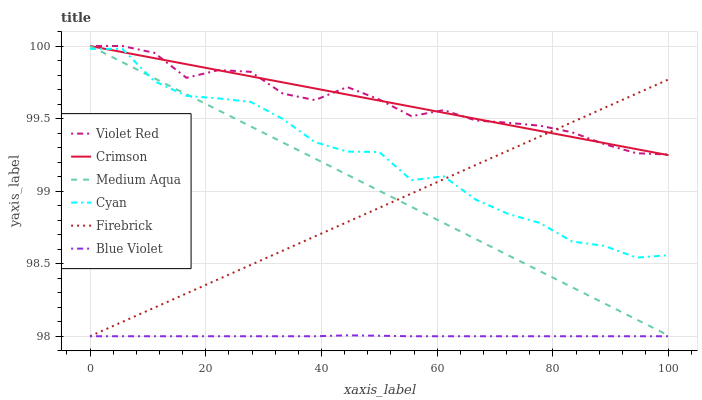Does Blue Violet have the minimum area under the curve?
Answer yes or no. Yes. Does Crimson have the maximum area under the curve?
Answer yes or no. Yes. Does Firebrick have the minimum area under the curve?
Answer yes or no. No. Does Firebrick have the maximum area under the curve?
Answer yes or no. No. Is Firebrick the smoothest?
Answer yes or no. Yes. Is Cyan the roughest?
Answer yes or no. Yes. Is Medium Aqua the smoothest?
Answer yes or no. No. Is Medium Aqua the roughest?
Answer yes or no. No. Does Firebrick have the lowest value?
Answer yes or no. Yes. Does Medium Aqua have the lowest value?
Answer yes or no. No. Does Crimson have the highest value?
Answer yes or no. Yes. Does Firebrick have the highest value?
Answer yes or no. No. Is Blue Violet less than Violet Red?
Answer yes or no. Yes. Is Violet Red greater than Cyan?
Answer yes or no. Yes. Does Cyan intersect Firebrick?
Answer yes or no. Yes. Is Cyan less than Firebrick?
Answer yes or no. No. Is Cyan greater than Firebrick?
Answer yes or no. No. Does Blue Violet intersect Violet Red?
Answer yes or no. No. 